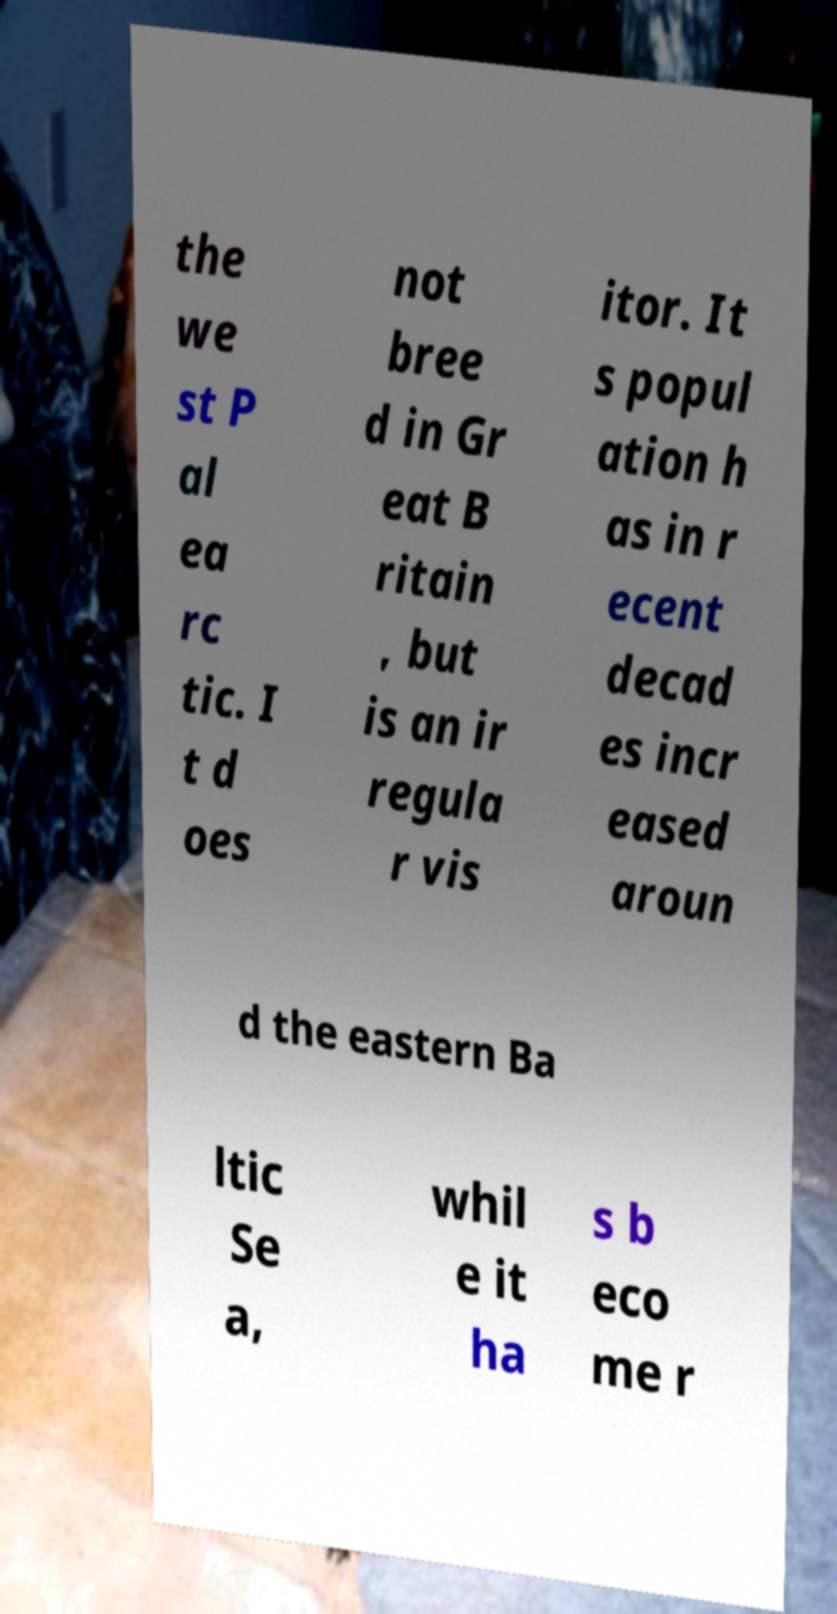Could you extract and type out the text from this image? the we st P al ea rc tic. I t d oes not bree d in Gr eat B ritain , but is an ir regula r vis itor. It s popul ation h as in r ecent decad es incr eased aroun d the eastern Ba ltic Se a, whil e it ha s b eco me r 